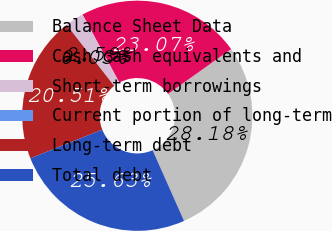<chart> <loc_0><loc_0><loc_500><loc_500><pie_chart><fcel>Balance Sheet Data<fcel>Cash cash equivalents and<fcel>Short-term borrowings<fcel>Current portion of long-term<fcel>Long-term debt<fcel>Total debt<nl><fcel>28.18%<fcel>23.07%<fcel>2.59%<fcel>0.03%<fcel>20.51%<fcel>25.63%<nl></chart> 